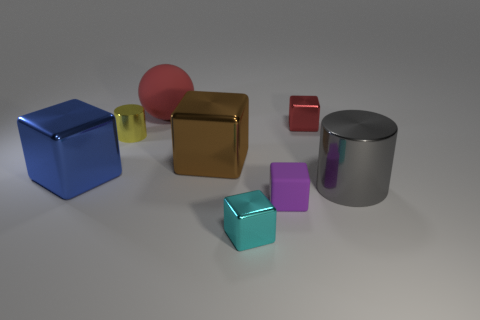Add 2 yellow spheres. How many objects exist? 10 Subtract all red blocks. How many blocks are left? 4 Subtract all small purple rubber blocks. How many blocks are left? 4 Subtract 1 cylinders. How many cylinders are left? 1 Subtract all cylinders. How many objects are left? 6 Subtract all yellow rubber balls. Subtract all tiny yellow cylinders. How many objects are left? 7 Add 7 big brown things. How many big brown things are left? 8 Add 5 spheres. How many spheres exist? 6 Subtract 0 cyan spheres. How many objects are left? 8 Subtract all purple cylinders. Subtract all yellow blocks. How many cylinders are left? 2 